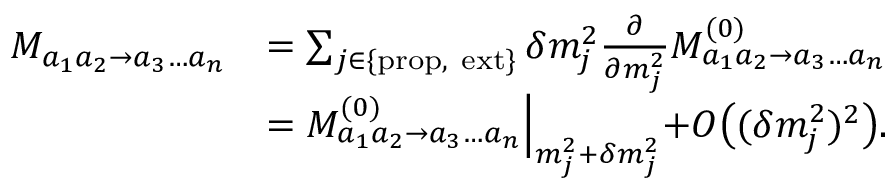Convert formula to latex. <formula><loc_0><loc_0><loc_500><loc_500>\begin{array} { r l } { M _ { a _ { 1 } a _ { 2 } \to a _ { 3 } \dots a _ { n } } } & { = \sum _ { { j \in \{ p r o p , e x t \} } } \delta m _ { j } ^ { 2 } \frac { \partial } { \partial m _ { j } ^ { 2 } } M _ { a _ { 1 } a _ { 2 } \to a _ { 3 } \dots a _ { n } } ^ { ( 0 ) } } \\ & { = M _ { a _ { 1 } a _ { 2 } \to a _ { 3 } \dots a _ { n } } ^ { ( 0 ) } \Big | _ { m _ { j } ^ { 2 } + \delta m _ { j } ^ { 2 } } + O \Big ( ( \delta m _ { j } ^ { 2 } ) ^ { 2 } \Big ) . } \end{array}</formula> 